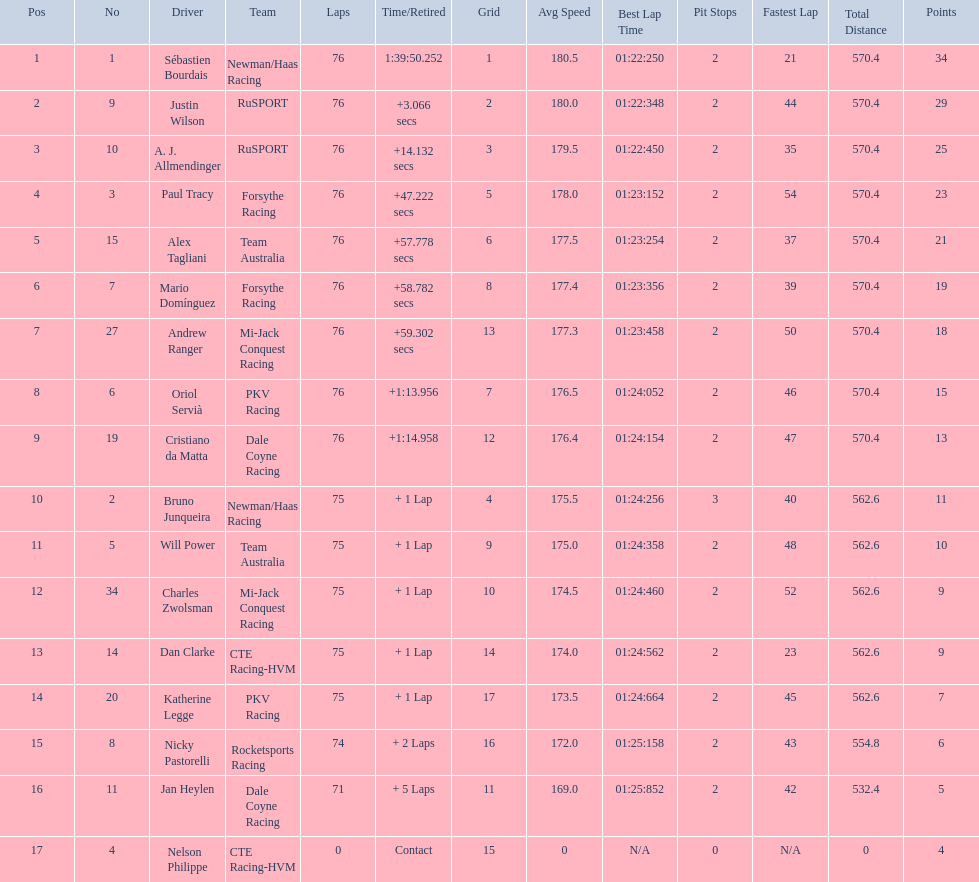How many points did charles zwolsman acquire? 9. Who else got 9 points? Dan Clarke. 